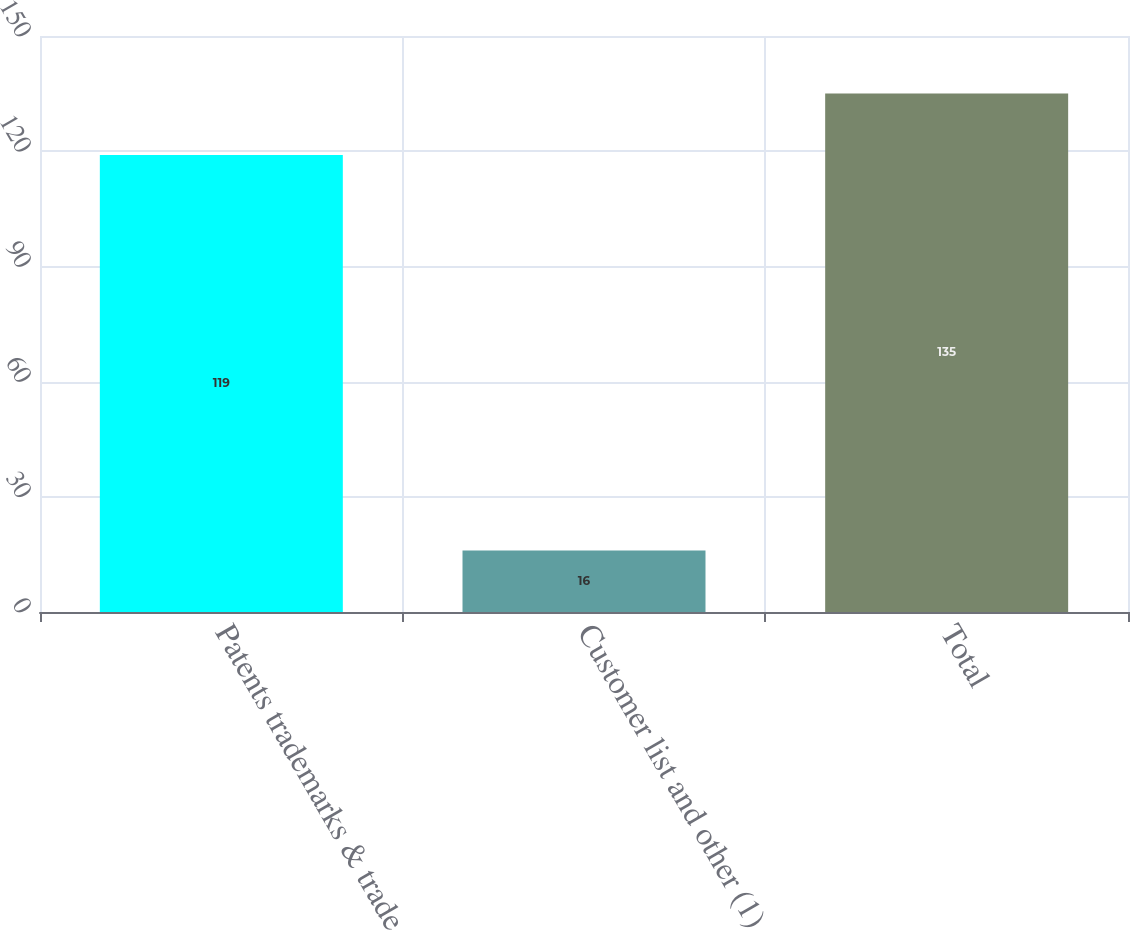Convert chart. <chart><loc_0><loc_0><loc_500><loc_500><bar_chart><fcel>Patents trademarks & trade<fcel>Customer list and other (1)<fcel>Total<nl><fcel>119<fcel>16<fcel>135<nl></chart> 